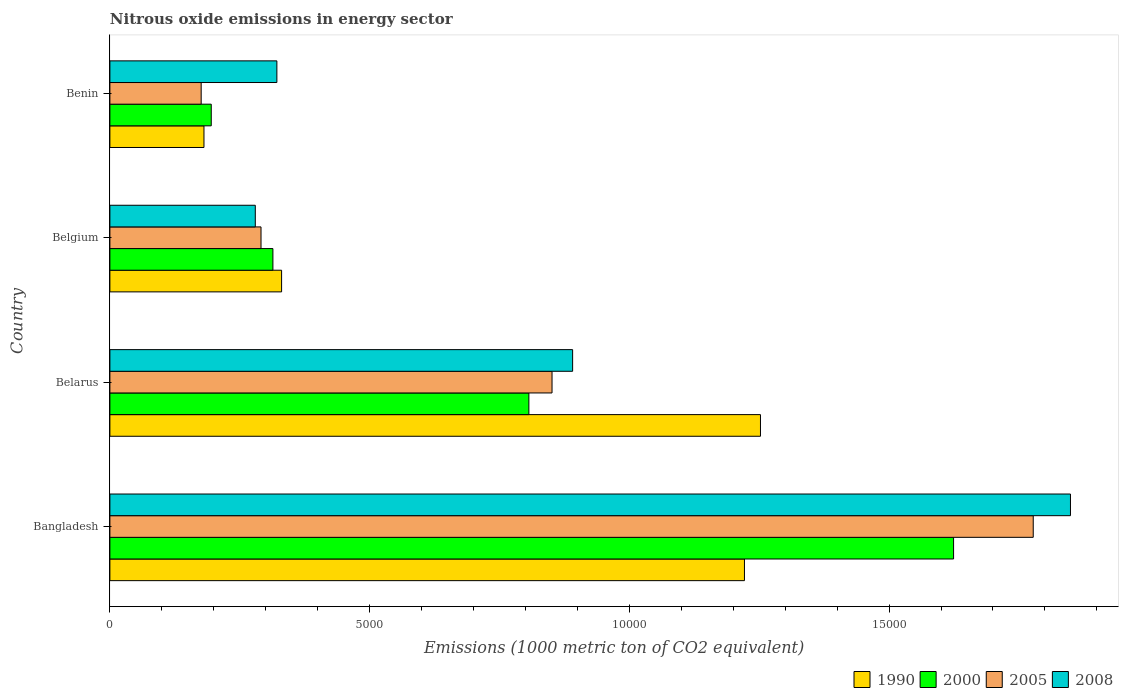How many groups of bars are there?
Offer a very short reply. 4. Are the number of bars per tick equal to the number of legend labels?
Provide a short and direct response. Yes. Are the number of bars on each tick of the Y-axis equal?
Your answer should be compact. Yes. How many bars are there on the 2nd tick from the bottom?
Your answer should be compact. 4. What is the label of the 2nd group of bars from the top?
Your answer should be compact. Belgium. What is the amount of nitrous oxide emitted in 2005 in Belgium?
Keep it short and to the point. 2909.4. Across all countries, what is the maximum amount of nitrous oxide emitted in 1990?
Your answer should be compact. 1.25e+04. Across all countries, what is the minimum amount of nitrous oxide emitted in 1990?
Give a very brief answer. 1811.1. In which country was the amount of nitrous oxide emitted in 1990 minimum?
Offer a terse response. Benin. What is the total amount of nitrous oxide emitted in 2005 in the graph?
Provide a short and direct response. 3.10e+04. What is the difference between the amount of nitrous oxide emitted in 2005 in Bangladesh and that in Belarus?
Offer a terse response. 9263.9. What is the difference between the amount of nitrous oxide emitted in 2000 in Belarus and the amount of nitrous oxide emitted in 2005 in Bangladesh?
Make the answer very short. -9709.6. What is the average amount of nitrous oxide emitted in 2008 per country?
Offer a terse response. 8353.75. What is the difference between the amount of nitrous oxide emitted in 2008 and amount of nitrous oxide emitted in 1990 in Bangladesh?
Keep it short and to the point. 6276.2. What is the ratio of the amount of nitrous oxide emitted in 2005 in Belarus to that in Belgium?
Ensure brevity in your answer.  2.93. Is the difference between the amount of nitrous oxide emitted in 2008 in Belgium and Benin greater than the difference between the amount of nitrous oxide emitted in 1990 in Belgium and Benin?
Make the answer very short. No. What is the difference between the highest and the second highest amount of nitrous oxide emitted in 1990?
Provide a short and direct response. 308.3. What is the difference between the highest and the lowest amount of nitrous oxide emitted in 1990?
Keep it short and to the point. 1.07e+04. In how many countries, is the amount of nitrous oxide emitted in 1990 greater than the average amount of nitrous oxide emitted in 1990 taken over all countries?
Make the answer very short. 2. Is it the case that in every country, the sum of the amount of nitrous oxide emitted in 2000 and amount of nitrous oxide emitted in 2008 is greater than the sum of amount of nitrous oxide emitted in 2005 and amount of nitrous oxide emitted in 1990?
Ensure brevity in your answer.  Yes. What does the 2nd bar from the top in Belarus represents?
Offer a terse response. 2005. Is it the case that in every country, the sum of the amount of nitrous oxide emitted in 2000 and amount of nitrous oxide emitted in 2008 is greater than the amount of nitrous oxide emitted in 1990?
Your answer should be very brief. Yes. How many bars are there?
Provide a succinct answer. 16. How many countries are there in the graph?
Offer a terse response. 4. What is the difference between two consecutive major ticks on the X-axis?
Keep it short and to the point. 5000. Does the graph contain any zero values?
Your response must be concise. No. Does the graph contain grids?
Your response must be concise. No. How many legend labels are there?
Provide a succinct answer. 4. What is the title of the graph?
Make the answer very short. Nitrous oxide emissions in energy sector. Does "1967" appear as one of the legend labels in the graph?
Provide a succinct answer. No. What is the label or title of the X-axis?
Ensure brevity in your answer.  Emissions (1000 metric ton of CO2 equivalent). What is the Emissions (1000 metric ton of CO2 equivalent) in 1990 in Bangladesh?
Your answer should be compact. 1.22e+04. What is the Emissions (1000 metric ton of CO2 equivalent) of 2000 in Bangladesh?
Provide a short and direct response. 1.62e+04. What is the Emissions (1000 metric ton of CO2 equivalent) in 2005 in Bangladesh?
Your answer should be compact. 1.78e+04. What is the Emissions (1000 metric ton of CO2 equivalent) of 2008 in Bangladesh?
Keep it short and to the point. 1.85e+04. What is the Emissions (1000 metric ton of CO2 equivalent) of 1990 in Belarus?
Provide a succinct answer. 1.25e+04. What is the Emissions (1000 metric ton of CO2 equivalent) in 2000 in Belarus?
Make the answer very short. 8066.2. What is the Emissions (1000 metric ton of CO2 equivalent) of 2005 in Belarus?
Keep it short and to the point. 8511.9. What is the Emissions (1000 metric ton of CO2 equivalent) of 2008 in Belarus?
Offer a very short reply. 8908.4. What is the Emissions (1000 metric ton of CO2 equivalent) of 1990 in Belgium?
Offer a very short reply. 3305.4. What is the Emissions (1000 metric ton of CO2 equivalent) of 2000 in Belgium?
Keep it short and to the point. 3138.4. What is the Emissions (1000 metric ton of CO2 equivalent) of 2005 in Belgium?
Give a very brief answer. 2909.4. What is the Emissions (1000 metric ton of CO2 equivalent) in 2008 in Belgium?
Give a very brief answer. 2799.3. What is the Emissions (1000 metric ton of CO2 equivalent) of 1990 in Benin?
Your answer should be compact. 1811.1. What is the Emissions (1000 metric ton of CO2 equivalent) of 2000 in Benin?
Offer a terse response. 1951.3. What is the Emissions (1000 metric ton of CO2 equivalent) in 2005 in Benin?
Offer a very short reply. 1757.4. What is the Emissions (1000 metric ton of CO2 equivalent) of 2008 in Benin?
Offer a terse response. 3214.8. Across all countries, what is the maximum Emissions (1000 metric ton of CO2 equivalent) in 1990?
Your answer should be compact. 1.25e+04. Across all countries, what is the maximum Emissions (1000 metric ton of CO2 equivalent) in 2000?
Keep it short and to the point. 1.62e+04. Across all countries, what is the maximum Emissions (1000 metric ton of CO2 equivalent) in 2005?
Offer a terse response. 1.78e+04. Across all countries, what is the maximum Emissions (1000 metric ton of CO2 equivalent) in 2008?
Provide a succinct answer. 1.85e+04. Across all countries, what is the minimum Emissions (1000 metric ton of CO2 equivalent) in 1990?
Your answer should be compact. 1811.1. Across all countries, what is the minimum Emissions (1000 metric ton of CO2 equivalent) in 2000?
Provide a succinct answer. 1951.3. Across all countries, what is the minimum Emissions (1000 metric ton of CO2 equivalent) in 2005?
Offer a very short reply. 1757.4. Across all countries, what is the minimum Emissions (1000 metric ton of CO2 equivalent) of 2008?
Give a very brief answer. 2799.3. What is the total Emissions (1000 metric ton of CO2 equivalent) of 1990 in the graph?
Make the answer very short. 2.99e+04. What is the total Emissions (1000 metric ton of CO2 equivalent) of 2000 in the graph?
Make the answer very short. 2.94e+04. What is the total Emissions (1000 metric ton of CO2 equivalent) of 2005 in the graph?
Keep it short and to the point. 3.10e+04. What is the total Emissions (1000 metric ton of CO2 equivalent) in 2008 in the graph?
Give a very brief answer. 3.34e+04. What is the difference between the Emissions (1000 metric ton of CO2 equivalent) of 1990 in Bangladesh and that in Belarus?
Give a very brief answer. -308.3. What is the difference between the Emissions (1000 metric ton of CO2 equivalent) in 2000 in Bangladesh and that in Belarus?
Give a very brief answer. 8176.2. What is the difference between the Emissions (1000 metric ton of CO2 equivalent) in 2005 in Bangladesh and that in Belarus?
Offer a terse response. 9263.9. What is the difference between the Emissions (1000 metric ton of CO2 equivalent) of 2008 in Bangladesh and that in Belarus?
Your answer should be very brief. 9584.1. What is the difference between the Emissions (1000 metric ton of CO2 equivalent) of 1990 in Bangladesh and that in Belgium?
Provide a succinct answer. 8910.9. What is the difference between the Emissions (1000 metric ton of CO2 equivalent) in 2000 in Bangladesh and that in Belgium?
Give a very brief answer. 1.31e+04. What is the difference between the Emissions (1000 metric ton of CO2 equivalent) of 2005 in Bangladesh and that in Belgium?
Your answer should be compact. 1.49e+04. What is the difference between the Emissions (1000 metric ton of CO2 equivalent) of 2008 in Bangladesh and that in Belgium?
Your response must be concise. 1.57e+04. What is the difference between the Emissions (1000 metric ton of CO2 equivalent) of 1990 in Bangladesh and that in Benin?
Offer a terse response. 1.04e+04. What is the difference between the Emissions (1000 metric ton of CO2 equivalent) of 2000 in Bangladesh and that in Benin?
Your response must be concise. 1.43e+04. What is the difference between the Emissions (1000 metric ton of CO2 equivalent) of 2005 in Bangladesh and that in Benin?
Offer a terse response. 1.60e+04. What is the difference between the Emissions (1000 metric ton of CO2 equivalent) of 2008 in Bangladesh and that in Benin?
Offer a terse response. 1.53e+04. What is the difference between the Emissions (1000 metric ton of CO2 equivalent) of 1990 in Belarus and that in Belgium?
Ensure brevity in your answer.  9219.2. What is the difference between the Emissions (1000 metric ton of CO2 equivalent) in 2000 in Belarus and that in Belgium?
Make the answer very short. 4927.8. What is the difference between the Emissions (1000 metric ton of CO2 equivalent) of 2005 in Belarus and that in Belgium?
Your answer should be very brief. 5602.5. What is the difference between the Emissions (1000 metric ton of CO2 equivalent) of 2008 in Belarus and that in Belgium?
Offer a very short reply. 6109.1. What is the difference between the Emissions (1000 metric ton of CO2 equivalent) of 1990 in Belarus and that in Benin?
Offer a very short reply. 1.07e+04. What is the difference between the Emissions (1000 metric ton of CO2 equivalent) of 2000 in Belarus and that in Benin?
Your answer should be compact. 6114.9. What is the difference between the Emissions (1000 metric ton of CO2 equivalent) in 2005 in Belarus and that in Benin?
Provide a succinct answer. 6754.5. What is the difference between the Emissions (1000 metric ton of CO2 equivalent) in 2008 in Belarus and that in Benin?
Give a very brief answer. 5693.6. What is the difference between the Emissions (1000 metric ton of CO2 equivalent) in 1990 in Belgium and that in Benin?
Provide a succinct answer. 1494.3. What is the difference between the Emissions (1000 metric ton of CO2 equivalent) in 2000 in Belgium and that in Benin?
Offer a terse response. 1187.1. What is the difference between the Emissions (1000 metric ton of CO2 equivalent) in 2005 in Belgium and that in Benin?
Your answer should be compact. 1152. What is the difference between the Emissions (1000 metric ton of CO2 equivalent) of 2008 in Belgium and that in Benin?
Give a very brief answer. -415.5. What is the difference between the Emissions (1000 metric ton of CO2 equivalent) of 1990 in Bangladesh and the Emissions (1000 metric ton of CO2 equivalent) of 2000 in Belarus?
Your answer should be very brief. 4150.1. What is the difference between the Emissions (1000 metric ton of CO2 equivalent) of 1990 in Bangladesh and the Emissions (1000 metric ton of CO2 equivalent) of 2005 in Belarus?
Give a very brief answer. 3704.4. What is the difference between the Emissions (1000 metric ton of CO2 equivalent) of 1990 in Bangladesh and the Emissions (1000 metric ton of CO2 equivalent) of 2008 in Belarus?
Your answer should be compact. 3307.9. What is the difference between the Emissions (1000 metric ton of CO2 equivalent) of 2000 in Bangladesh and the Emissions (1000 metric ton of CO2 equivalent) of 2005 in Belarus?
Make the answer very short. 7730.5. What is the difference between the Emissions (1000 metric ton of CO2 equivalent) in 2000 in Bangladesh and the Emissions (1000 metric ton of CO2 equivalent) in 2008 in Belarus?
Make the answer very short. 7334. What is the difference between the Emissions (1000 metric ton of CO2 equivalent) of 2005 in Bangladesh and the Emissions (1000 metric ton of CO2 equivalent) of 2008 in Belarus?
Make the answer very short. 8867.4. What is the difference between the Emissions (1000 metric ton of CO2 equivalent) of 1990 in Bangladesh and the Emissions (1000 metric ton of CO2 equivalent) of 2000 in Belgium?
Keep it short and to the point. 9077.9. What is the difference between the Emissions (1000 metric ton of CO2 equivalent) of 1990 in Bangladesh and the Emissions (1000 metric ton of CO2 equivalent) of 2005 in Belgium?
Offer a very short reply. 9306.9. What is the difference between the Emissions (1000 metric ton of CO2 equivalent) in 1990 in Bangladesh and the Emissions (1000 metric ton of CO2 equivalent) in 2008 in Belgium?
Keep it short and to the point. 9417. What is the difference between the Emissions (1000 metric ton of CO2 equivalent) of 2000 in Bangladesh and the Emissions (1000 metric ton of CO2 equivalent) of 2005 in Belgium?
Provide a succinct answer. 1.33e+04. What is the difference between the Emissions (1000 metric ton of CO2 equivalent) in 2000 in Bangladesh and the Emissions (1000 metric ton of CO2 equivalent) in 2008 in Belgium?
Make the answer very short. 1.34e+04. What is the difference between the Emissions (1000 metric ton of CO2 equivalent) of 2005 in Bangladesh and the Emissions (1000 metric ton of CO2 equivalent) of 2008 in Belgium?
Your answer should be compact. 1.50e+04. What is the difference between the Emissions (1000 metric ton of CO2 equivalent) of 1990 in Bangladesh and the Emissions (1000 metric ton of CO2 equivalent) of 2000 in Benin?
Make the answer very short. 1.03e+04. What is the difference between the Emissions (1000 metric ton of CO2 equivalent) of 1990 in Bangladesh and the Emissions (1000 metric ton of CO2 equivalent) of 2005 in Benin?
Keep it short and to the point. 1.05e+04. What is the difference between the Emissions (1000 metric ton of CO2 equivalent) of 1990 in Bangladesh and the Emissions (1000 metric ton of CO2 equivalent) of 2008 in Benin?
Your response must be concise. 9001.5. What is the difference between the Emissions (1000 metric ton of CO2 equivalent) of 2000 in Bangladesh and the Emissions (1000 metric ton of CO2 equivalent) of 2005 in Benin?
Provide a short and direct response. 1.45e+04. What is the difference between the Emissions (1000 metric ton of CO2 equivalent) of 2000 in Bangladesh and the Emissions (1000 metric ton of CO2 equivalent) of 2008 in Benin?
Your answer should be compact. 1.30e+04. What is the difference between the Emissions (1000 metric ton of CO2 equivalent) in 2005 in Bangladesh and the Emissions (1000 metric ton of CO2 equivalent) in 2008 in Benin?
Keep it short and to the point. 1.46e+04. What is the difference between the Emissions (1000 metric ton of CO2 equivalent) of 1990 in Belarus and the Emissions (1000 metric ton of CO2 equivalent) of 2000 in Belgium?
Your answer should be compact. 9386.2. What is the difference between the Emissions (1000 metric ton of CO2 equivalent) in 1990 in Belarus and the Emissions (1000 metric ton of CO2 equivalent) in 2005 in Belgium?
Give a very brief answer. 9615.2. What is the difference between the Emissions (1000 metric ton of CO2 equivalent) in 1990 in Belarus and the Emissions (1000 metric ton of CO2 equivalent) in 2008 in Belgium?
Give a very brief answer. 9725.3. What is the difference between the Emissions (1000 metric ton of CO2 equivalent) in 2000 in Belarus and the Emissions (1000 metric ton of CO2 equivalent) in 2005 in Belgium?
Keep it short and to the point. 5156.8. What is the difference between the Emissions (1000 metric ton of CO2 equivalent) in 2000 in Belarus and the Emissions (1000 metric ton of CO2 equivalent) in 2008 in Belgium?
Give a very brief answer. 5266.9. What is the difference between the Emissions (1000 metric ton of CO2 equivalent) in 2005 in Belarus and the Emissions (1000 metric ton of CO2 equivalent) in 2008 in Belgium?
Ensure brevity in your answer.  5712.6. What is the difference between the Emissions (1000 metric ton of CO2 equivalent) in 1990 in Belarus and the Emissions (1000 metric ton of CO2 equivalent) in 2000 in Benin?
Ensure brevity in your answer.  1.06e+04. What is the difference between the Emissions (1000 metric ton of CO2 equivalent) of 1990 in Belarus and the Emissions (1000 metric ton of CO2 equivalent) of 2005 in Benin?
Your response must be concise. 1.08e+04. What is the difference between the Emissions (1000 metric ton of CO2 equivalent) of 1990 in Belarus and the Emissions (1000 metric ton of CO2 equivalent) of 2008 in Benin?
Offer a terse response. 9309.8. What is the difference between the Emissions (1000 metric ton of CO2 equivalent) in 2000 in Belarus and the Emissions (1000 metric ton of CO2 equivalent) in 2005 in Benin?
Provide a succinct answer. 6308.8. What is the difference between the Emissions (1000 metric ton of CO2 equivalent) in 2000 in Belarus and the Emissions (1000 metric ton of CO2 equivalent) in 2008 in Benin?
Your answer should be compact. 4851.4. What is the difference between the Emissions (1000 metric ton of CO2 equivalent) in 2005 in Belarus and the Emissions (1000 metric ton of CO2 equivalent) in 2008 in Benin?
Provide a succinct answer. 5297.1. What is the difference between the Emissions (1000 metric ton of CO2 equivalent) in 1990 in Belgium and the Emissions (1000 metric ton of CO2 equivalent) in 2000 in Benin?
Give a very brief answer. 1354.1. What is the difference between the Emissions (1000 metric ton of CO2 equivalent) in 1990 in Belgium and the Emissions (1000 metric ton of CO2 equivalent) in 2005 in Benin?
Offer a very short reply. 1548. What is the difference between the Emissions (1000 metric ton of CO2 equivalent) of 1990 in Belgium and the Emissions (1000 metric ton of CO2 equivalent) of 2008 in Benin?
Give a very brief answer. 90.6. What is the difference between the Emissions (1000 metric ton of CO2 equivalent) of 2000 in Belgium and the Emissions (1000 metric ton of CO2 equivalent) of 2005 in Benin?
Provide a succinct answer. 1381. What is the difference between the Emissions (1000 metric ton of CO2 equivalent) of 2000 in Belgium and the Emissions (1000 metric ton of CO2 equivalent) of 2008 in Benin?
Offer a terse response. -76.4. What is the difference between the Emissions (1000 metric ton of CO2 equivalent) of 2005 in Belgium and the Emissions (1000 metric ton of CO2 equivalent) of 2008 in Benin?
Ensure brevity in your answer.  -305.4. What is the average Emissions (1000 metric ton of CO2 equivalent) in 1990 per country?
Your response must be concise. 7464.35. What is the average Emissions (1000 metric ton of CO2 equivalent) of 2000 per country?
Your answer should be compact. 7349.57. What is the average Emissions (1000 metric ton of CO2 equivalent) in 2005 per country?
Your answer should be very brief. 7738.62. What is the average Emissions (1000 metric ton of CO2 equivalent) of 2008 per country?
Offer a terse response. 8353.75. What is the difference between the Emissions (1000 metric ton of CO2 equivalent) in 1990 and Emissions (1000 metric ton of CO2 equivalent) in 2000 in Bangladesh?
Offer a very short reply. -4026.1. What is the difference between the Emissions (1000 metric ton of CO2 equivalent) in 1990 and Emissions (1000 metric ton of CO2 equivalent) in 2005 in Bangladesh?
Provide a short and direct response. -5559.5. What is the difference between the Emissions (1000 metric ton of CO2 equivalent) in 1990 and Emissions (1000 metric ton of CO2 equivalent) in 2008 in Bangladesh?
Offer a very short reply. -6276.2. What is the difference between the Emissions (1000 metric ton of CO2 equivalent) in 2000 and Emissions (1000 metric ton of CO2 equivalent) in 2005 in Bangladesh?
Offer a terse response. -1533.4. What is the difference between the Emissions (1000 metric ton of CO2 equivalent) in 2000 and Emissions (1000 metric ton of CO2 equivalent) in 2008 in Bangladesh?
Offer a very short reply. -2250.1. What is the difference between the Emissions (1000 metric ton of CO2 equivalent) of 2005 and Emissions (1000 metric ton of CO2 equivalent) of 2008 in Bangladesh?
Make the answer very short. -716.7. What is the difference between the Emissions (1000 metric ton of CO2 equivalent) in 1990 and Emissions (1000 metric ton of CO2 equivalent) in 2000 in Belarus?
Provide a succinct answer. 4458.4. What is the difference between the Emissions (1000 metric ton of CO2 equivalent) in 1990 and Emissions (1000 metric ton of CO2 equivalent) in 2005 in Belarus?
Your answer should be compact. 4012.7. What is the difference between the Emissions (1000 metric ton of CO2 equivalent) in 1990 and Emissions (1000 metric ton of CO2 equivalent) in 2008 in Belarus?
Offer a very short reply. 3616.2. What is the difference between the Emissions (1000 metric ton of CO2 equivalent) of 2000 and Emissions (1000 metric ton of CO2 equivalent) of 2005 in Belarus?
Your response must be concise. -445.7. What is the difference between the Emissions (1000 metric ton of CO2 equivalent) of 2000 and Emissions (1000 metric ton of CO2 equivalent) of 2008 in Belarus?
Your answer should be very brief. -842.2. What is the difference between the Emissions (1000 metric ton of CO2 equivalent) of 2005 and Emissions (1000 metric ton of CO2 equivalent) of 2008 in Belarus?
Offer a very short reply. -396.5. What is the difference between the Emissions (1000 metric ton of CO2 equivalent) of 1990 and Emissions (1000 metric ton of CO2 equivalent) of 2000 in Belgium?
Give a very brief answer. 167. What is the difference between the Emissions (1000 metric ton of CO2 equivalent) of 1990 and Emissions (1000 metric ton of CO2 equivalent) of 2005 in Belgium?
Ensure brevity in your answer.  396. What is the difference between the Emissions (1000 metric ton of CO2 equivalent) of 1990 and Emissions (1000 metric ton of CO2 equivalent) of 2008 in Belgium?
Your answer should be compact. 506.1. What is the difference between the Emissions (1000 metric ton of CO2 equivalent) in 2000 and Emissions (1000 metric ton of CO2 equivalent) in 2005 in Belgium?
Keep it short and to the point. 229. What is the difference between the Emissions (1000 metric ton of CO2 equivalent) of 2000 and Emissions (1000 metric ton of CO2 equivalent) of 2008 in Belgium?
Your answer should be compact. 339.1. What is the difference between the Emissions (1000 metric ton of CO2 equivalent) in 2005 and Emissions (1000 metric ton of CO2 equivalent) in 2008 in Belgium?
Offer a very short reply. 110.1. What is the difference between the Emissions (1000 metric ton of CO2 equivalent) of 1990 and Emissions (1000 metric ton of CO2 equivalent) of 2000 in Benin?
Provide a succinct answer. -140.2. What is the difference between the Emissions (1000 metric ton of CO2 equivalent) in 1990 and Emissions (1000 metric ton of CO2 equivalent) in 2005 in Benin?
Provide a succinct answer. 53.7. What is the difference between the Emissions (1000 metric ton of CO2 equivalent) of 1990 and Emissions (1000 metric ton of CO2 equivalent) of 2008 in Benin?
Give a very brief answer. -1403.7. What is the difference between the Emissions (1000 metric ton of CO2 equivalent) of 2000 and Emissions (1000 metric ton of CO2 equivalent) of 2005 in Benin?
Ensure brevity in your answer.  193.9. What is the difference between the Emissions (1000 metric ton of CO2 equivalent) in 2000 and Emissions (1000 metric ton of CO2 equivalent) in 2008 in Benin?
Your response must be concise. -1263.5. What is the difference between the Emissions (1000 metric ton of CO2 equivalent) of 2005 and Emissions (1000 metric ton of CO2 equivalent) of 2008 in Benin?
Offer a terse response. -1457.4. What is the ratio of the Emissions (1000 metric ton of CO2 equivalent) of 1990 in Bangladesh to that in Belarus?
Provide a short and direct response. 0.98. What is the ratio of the Emissions (1000 metric ton of CO2 equivalent) in 2000 in Bangladesh to that in Belarus?
Keep it short and to the point. 2.01. What is the ratio of the Emissions (1000 metric ton of CO2 equivalent) in 2005 in Bangladesh to that in Belarus?
Make the answer very short. 2.09. What is the ratio of the Emissions (1000 metric ton of CO2 equivalent) of 2008 in Bangladesh to that in Belarus?
Ensure brevity in your answer.  2.08. What is the ratio of the Emissions (1000 metric ton of CO2 equivalent) in 1990 in Bangladesh to that in Belgium?
Keep it short and to the point. 3.7. What is the ratio of the Emissions (1000 metric ton of CO2 equivalent) in 2000 in Bangladesh to that in Belgium?
Provide a succinct answer. 5.18. What is the ratio of the Emissions (1000 metric ton of CO2 equivalent) of 2005 in Bangladesh to that in Belgium?
Ensure brevity in your answer.  6.11. What is the ratio of the Emissions (1000 metric ton of CO2 equivalent) of 2008 in Bangladesh to that in Belgium?
Offer a terse response. 6.61. What is the ratio of the Emissions (1000 metric ton of CO2 equivalent) of 1990 in Bangladesh to that in Benin?
Your answer should be very brief. 6.75. What is the ratio of the Emissions (1000 metric ton of CO2 equivalent) in 2000 in Bangladesh to that in Benin?
Make the answer very short. 8.32. What is the ratio of the Emissions (1000 metric ton of CO2 equivalent) in 2005 in Bangladesh to that in Benin?
Provide a succinct answer. 10.11. What is the ratio of the Emissions (1000 metric ton of CO2 equivalent) of 2008 in Bangladesh to that in Benin?
Your answer should be very brief. 5.75. What is the ratio of the Emissions (1000 metric ton of CO2 equivalent) in 1990 in Belarus to that in Belgium?
Give a very brief answer. 3.79. What is the ratio of the Emissions (1000 metric ton of CO2 equivalent) of 2000 in Belarus to that in Belgium?
Offer a very short reply. 2.57. What is the ratio of the Emissions (1000 metric ton of CO2 equivalent) in 2005 in Belarus to that in Belgium?
Give a very brief answer. 2.93. What is the ratio of the Emissions (1000 metric ton of CO2 equivalent) in 2008 in Belarus to that in Belgium?
Provide a succinct answer. 3.18. What is the ratio of the Emissions (1000 metric ton of CO2 equivalent) in 1990 in Belarus to that in Benin?
Keep it short and to the point. 6.92. What is the ratio of the Emissions (1000 metric ton of CO2 equivalent) in 2000 in Belarus to that in Benin?
Offer a very short reply. 4.13. What is the ratio of the Emissions (1000 metric ton of CO2 equivalent) in 2005 in Belarus to that in Benin?
Your answer should be compact. 4.84. What is the ratio of the Emissions (1000 metric ton of CO2 equivalent) in 2008 in Belarus to that in Benin?
Offer a terse response. 2.77. What is the ratio of the Emissions (1000 metric ton of CO2 equivalent) of 1990 in Belgium to that in Benin?
Ensure brevity in your answer.  1.83. What is the ratio of the Emissions (1000 metric ton of CO2 equivalent) in 2000 in Belgium to that in Benin?
Offer a very short reply. 1.61. What is the ratio of the Emissions (1000 metric ton of CO2 equivalent) in 2005 in Belgium to that in Benin?
Your response must be concise. 1.66. What is the ratio of the Emissions (1000 metric ton of CO2 equivalent) in 2008 in Belgium to that in Benin?
Offer a terse response. 0.87. What is the difference between the highest and the second highest Emissions (1000 metric ton of CO2 equivalent) of 1990?
Your answer should be compact. 308.3. What is the difference between the highest and the second highest Emissions (1000 metric ton of CO2 equivalent) in 2000?
Your answer should be compact. 8176.2. What is the difference between the highest and the second highest Emissions (1000 metric ton of CO2 equivalent) in 2005?
Provide a succinct answer. 9263.9. What is the difference between the highest and the second highest Emissions (1000 metric ton of CO2 equivalent) in 2008?
Provide a succinct answer. 9584.1. What is the difference between the highest and the lowest Emissions (1000 metric ton of CO2 equivalent) of 1990?
Provide a short and direct response. 1.07e+04. What is the difference between the highest and the lowest Emissions (1000 metric ton of CO2 equivalent) in 2000?
Your answer should be compact. 1.43e+04. What is the difference between the highest and the lowest Emissions (1000 metric ton of CO2 equivalent) in 2005?
Your answer should be compact. 1.60e+04. What is the difference between the highest and the lowest Emissions (1000 metric ton of CO2 equivalent) of 2008?
Ensure brevity in your answer.  1.57e+04. 